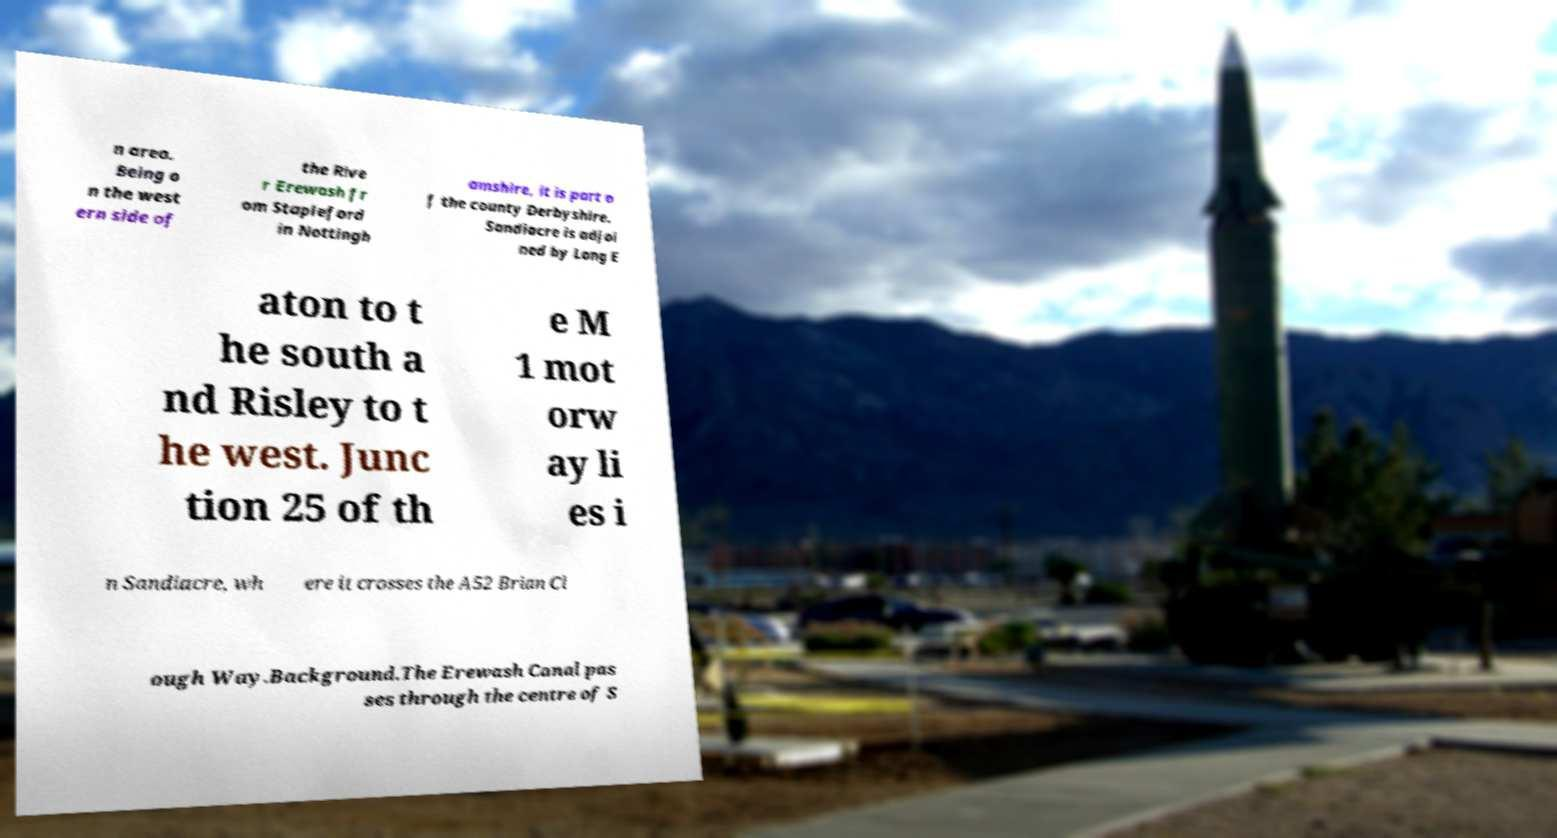What messages or text are displayed in this image? I need them in a readable, typed format. n area. Being o n the west ern side of the Rive r Erewash fr om Stapleford in Nottingh amshire, it is part o f the county Derbyshire. Sandiacre is adjoi ned by Long E aton to t he south a nd Risley to t he west. Junc tion 25 of th e M 1 mot orw ay li es i n Sandiacre, wh ere it crosses the A52 Brian Cl ough Way.Background.The Erewash Canal pas ses through the centre of S 